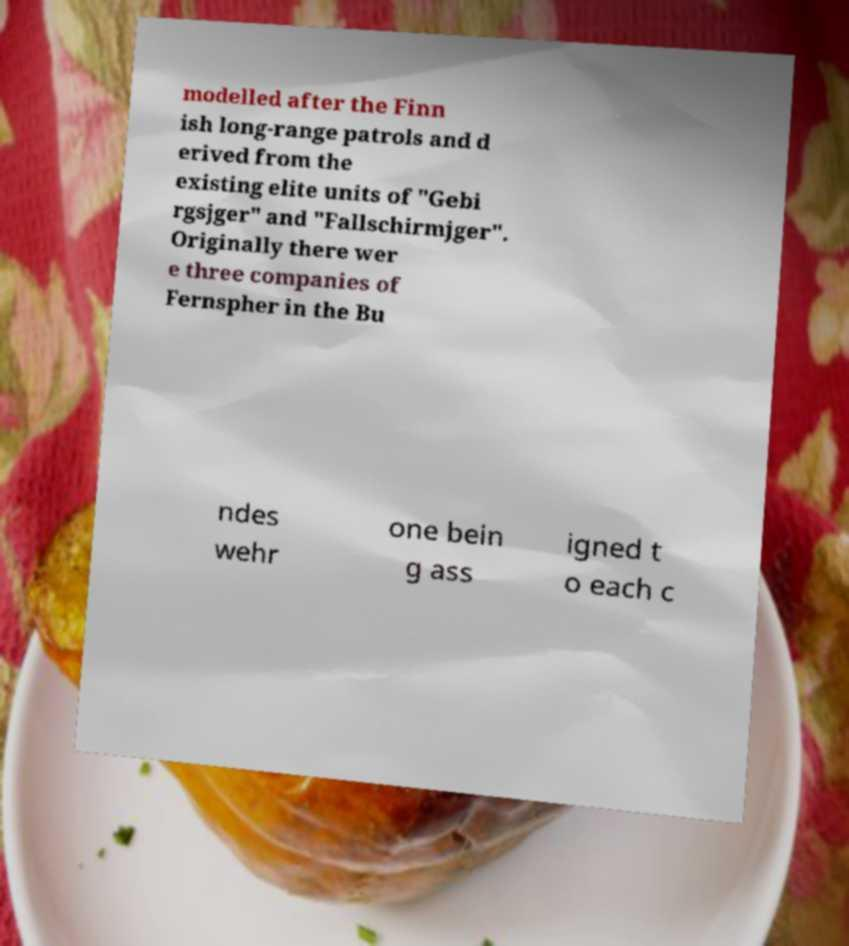There's text embedded in this image that I need extracted. Can you transcribe it verbatim? modelled after the Finn ish long-range patrols and d erived from the existing elite units of "Gebi rgsjger" and "Fallschirmjger". Originally there wer e three companies of Fernspher in the Bu ndes wehr one bein g ass igned t o each c 